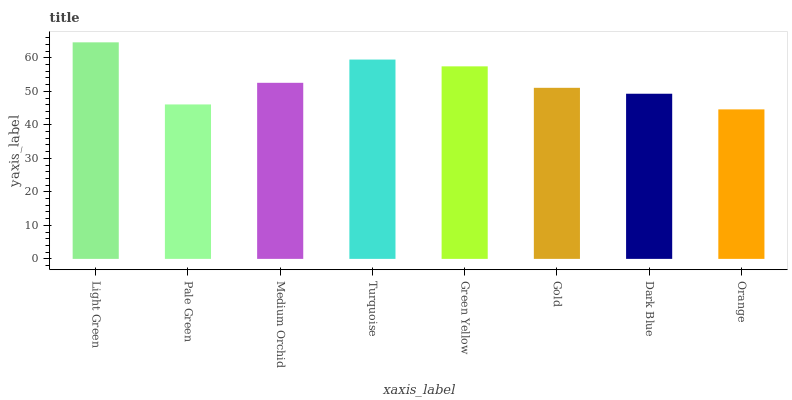Is Orange the minimum?
Answer yes or no. Yes. Is Light Green the maximum?
Answer yes or no. Yes. Is Pale Green the minimum?
Answer yes or no. No. Is Pale Green the maximum?
Answer yes or no. No. Is Light Green greater than Pale Green?
Answer yes or no. Yes. Is Pale Green less than Light Green?
Answer yes or no. Yes. Is Pale Green greater than Light Green?
Answer yes or no. No. Is Light Green less than Pale Green?
Answer yes or no. No. Is Medium Orchid the high median?
Answer yes or no. Yes. Is Gold the low median?
Answer yes or no. Yes. Is Turquoise the high median?
Answer yes or no. No. Is Green Yellow the low median?
Answer yes or no. No. 